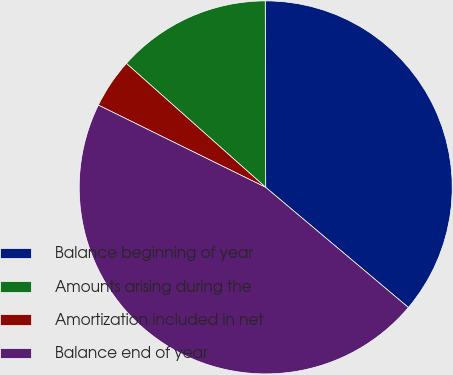Convert chart to OTSL. <chart><loc_0><loc_0><loc_500><loc_500><pie_chart><fcel>Balance beginning of year<fcel>Amounts arising during the<fcel>Amortization included in net<fcel>Balance end of year<nl><fcel>36.18%<fcel>13.39%<fcel>4.3%<fcel>46.14%<nl></chart> 